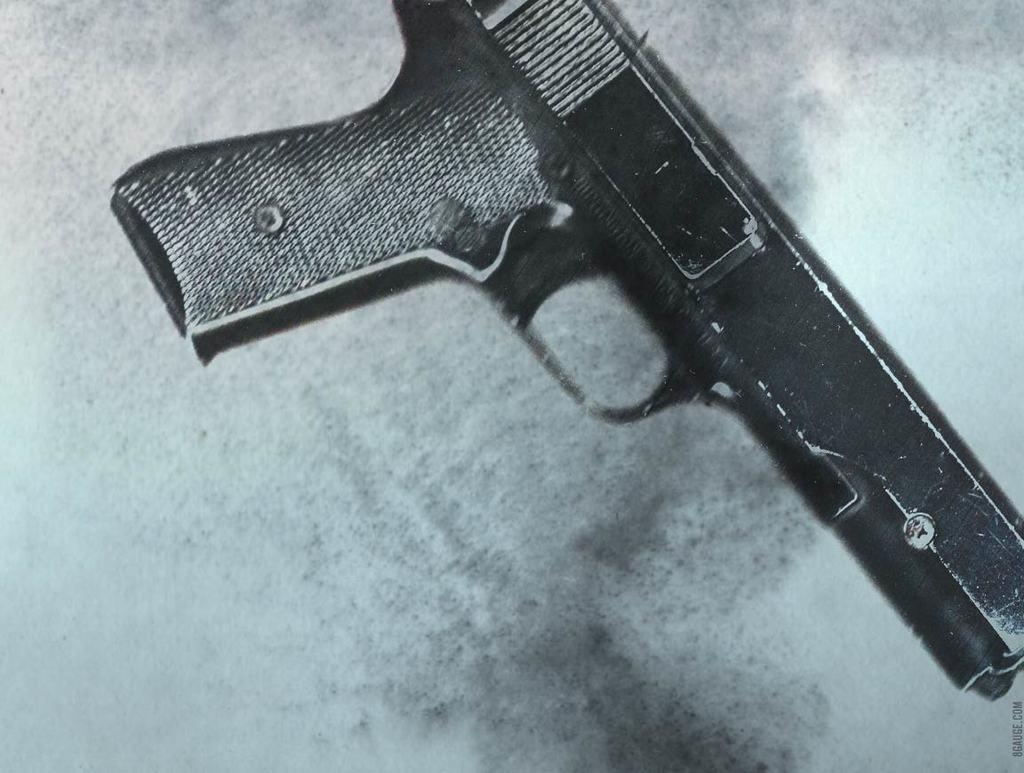What object is present on the table in the image? There is a gun on the table in the image. What type of organization is responsible for the growth of the gun in the image? There is no organization or growth related to the gun in the image; it is a static object on a table. 